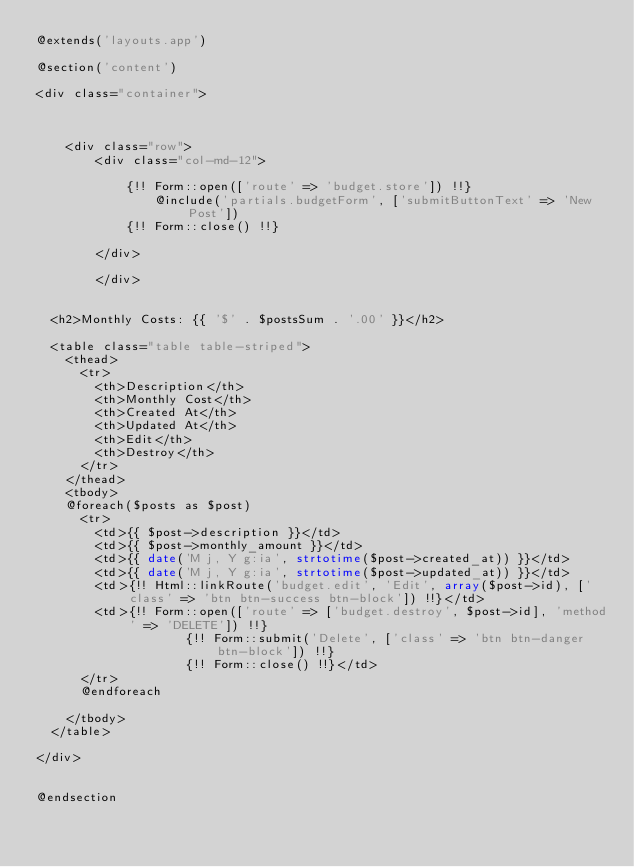Convert code to text. <code><loc_0><loc_0><loc_500><loc_500><_PHP_>@extends('layouts.app')

@section('content')

<div class="container">



    <div class="row">
        <div class="col-md-12">

            {!! Form::open(['route' => 'budget.store']) !!}
                @include('partials.budgetForm', ['submitButtonText' => 'New Post'])
            {!! Form::close() !!}

        </div>

        </div>


  <h2>Monthly Costs: {{ '$' . $postsSum . '.00' }}</h2>
             
  <table class="table table-striped">
    <thead>
      <tr>
        <th>Description</th>
        <th>Monthly Cost</th>
        <th>Created At</th>
        <th>Updated At</th>
        <th>Edit</th>
        <th>Destroy</th>
      </tr>
    </thead>
    <tbody>
    @foreach($posts as $post)
      <tr>
        <td>{{ $post->description }}</td>
        <td>{{ $post->monthly_amount }}</td>
        <td>{{ date('M j, Y g:ia', strtotime($post->created_at)) }}</td>
        <td>{{ date('M j, Y g:ia', strtotime($post->updated_at)) }}</td>
        <td>{!! Html::linkRoute('budget.edit', 'Edit', array($post->id), ['class' => 'btn btn-success btn-block']) !!}</td>
        <td>{!! Form::open(['route' => ['budget.destroy', $post->id], 'method' => 'DELETE']) !!}
                    {!! Form::submit('Delete', ['class' => 'btn btn-danger btn-block']) !!}
                    {!! Form::close() !!}</td>
      </tr>
      @endforeach
      
    </tbody>
  </table>

</div>


@endsection</code> 